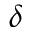Convert formula to latex. <formula><loc_0><loc_0><loc_500><loc_500>\delta</formula> 